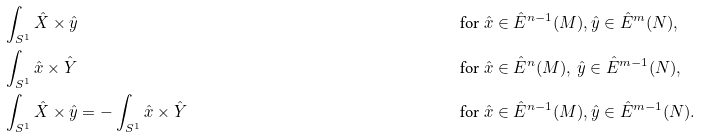Convert formula to latex. <formula><loc_0><loc_0><loc_500><loc_500>& \int _ { S ^ { 1 } } \hat { X } \times \hat { y } & & \text {for } \hat { x } \in \hat { E } ^ { n - 1 } ( M ) , \hat { y } \in \hat { E } ^ { m } ( N ) , \\ & \int _ { S ^ { 1 } } \hat { x } \times \hat { Y } & & \text {for } \hat { x } \in \hat { E } ^ { n } ( M ) , \, \hat { y } \in \hat { E } ^ { m - 1 } ( N ) , \\ & \int _ { S ^ { 1 } } \hat { X } \times \hat { y } = - \int _ { S ^ { 1 } } \hat { x } \times \hat { Y } & & \text {for } \hat { x } \in \hat { E } ^ { n - 1 } ( M ) , \hat { y } \in \hat { E } ^ { m - 1 } ( N ) .</formula> 